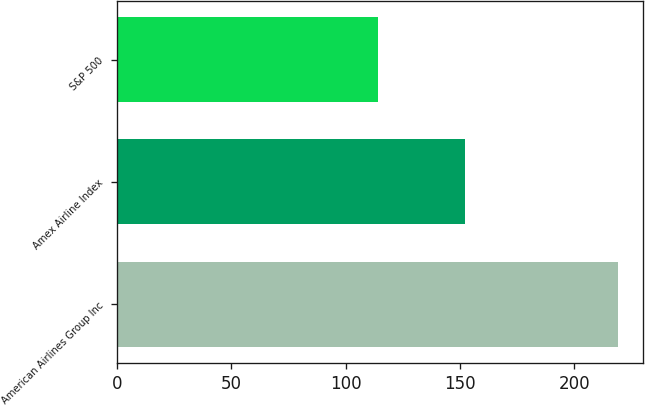Convert chart to OTSL. <chart><loc_0><loc_0><loc_500><loc_500><bar_chart><fcel>American Airlines Group Inc<fcel>Amex Airline Index<fcel>S&P 500<nl><fcel>219<fcel>152<fcel>114<nl></chart> 